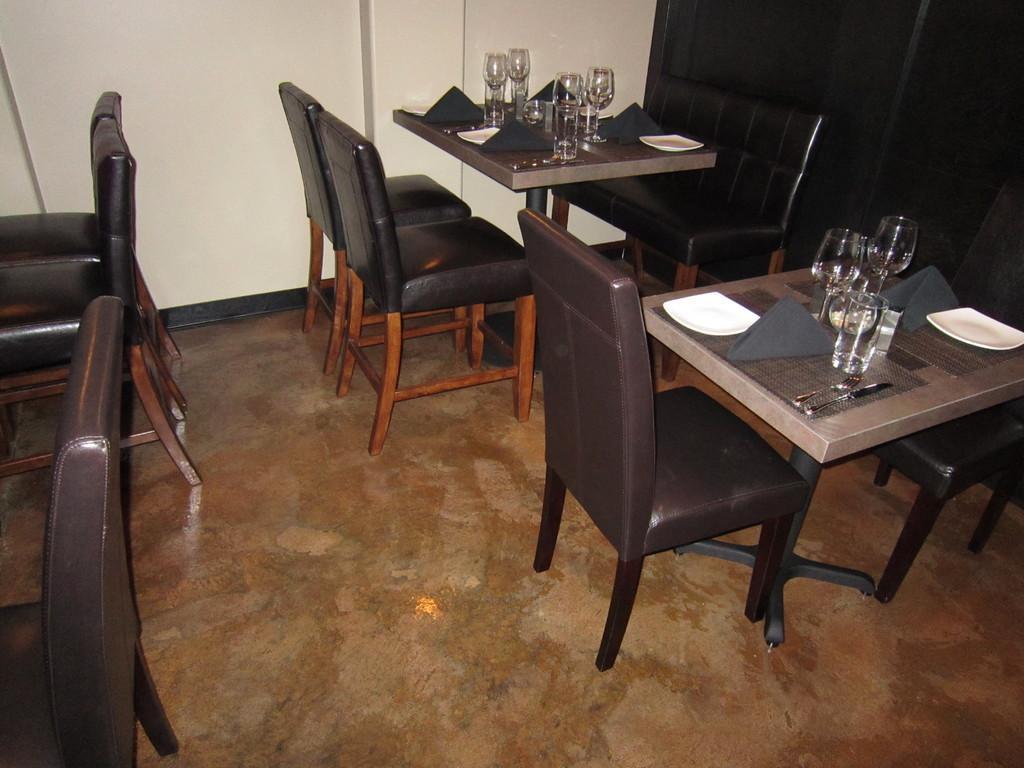Can you describe this image briefly? In this picture we can see few glasses, plates, knives and other things on the tables, also we can see few chairs. 